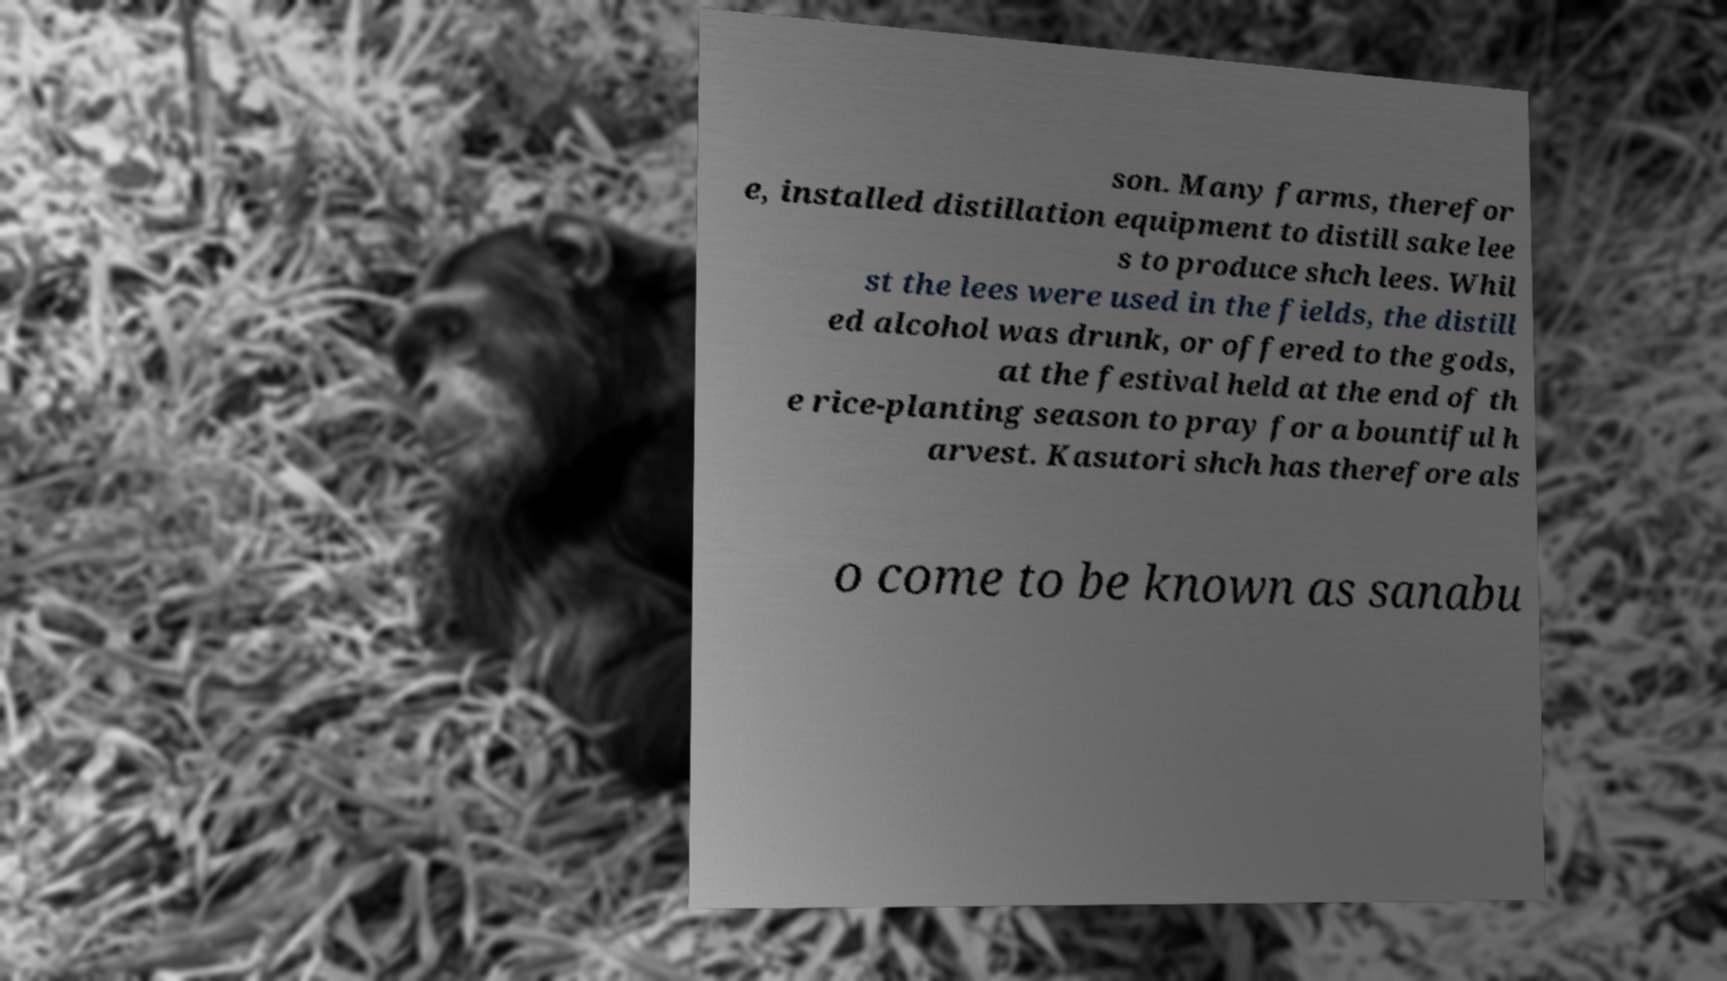Can you accurately transcribe the text from the provided image for me? son. Many farms, therefor e, installed distillation equipment to distill sake lee s to produce shch lees. Whil st the lees were used in the fields, the distill ed alcohol was drunk, or offered to the gods, at the festival held at the end of th e rice-planting season to pray for a bountiful h arvest. Kasutori shch has therefore als o come to be known as sanabu 